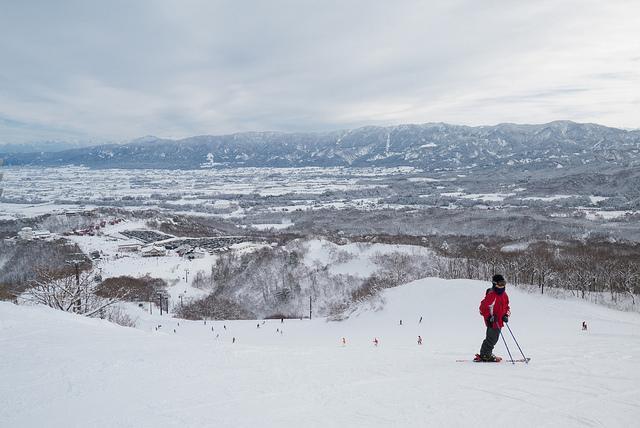How many people are pictured?
Give a very brief answer. 1. How many dogs are in the water?
Give a very brief answer. 0. 